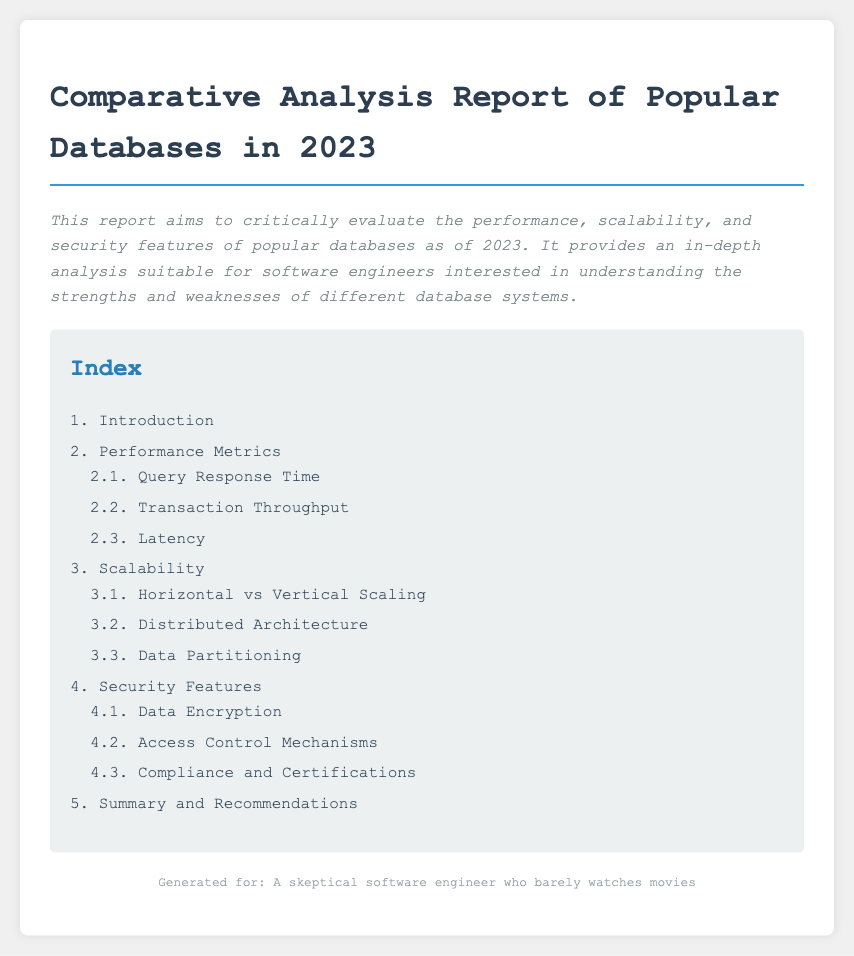What is the title of the report? The title of the report is specified in the document's header.
Answer: Comparative Analysis Report of Popular Databases in 2023 What are the three main evaluation areas in the report? The report explicitly states its main evaluation areas in the introduction section.
Answer: Performance, Scalability, Security What is included under "Performance Metrics"? This section's content is listed in the table of contents, indicating the areas covered under performance metrics.
Answer: Query Response Time, Transaction Throughput, Latency How many sections are there in the index? The number of sections is counted from the index provided in the document.
Answer: Five What is the purpose of the report? The purpose is summarized in the introductory paragraph.
Answer: To critically evaluate the performance, scalability, and security features of popular databases What sub-section covers access control mechanisms? This is directly mentioned in the index under the security features category.
Answer: 4.2. Access Control Mechanisms Which type of scaling is mentioned in the scalability section? The index outlines the comparison types in the scalability category.
Answer: Horizontal vs Vertical Scaling What is the style of the report's body text? The document specifies the style used for the body text in the CSS section.
Answer: Courier New, monospace What is the color of the index's header? The color is stated in the CSS styling for the index header.
Answer: #2980b9 